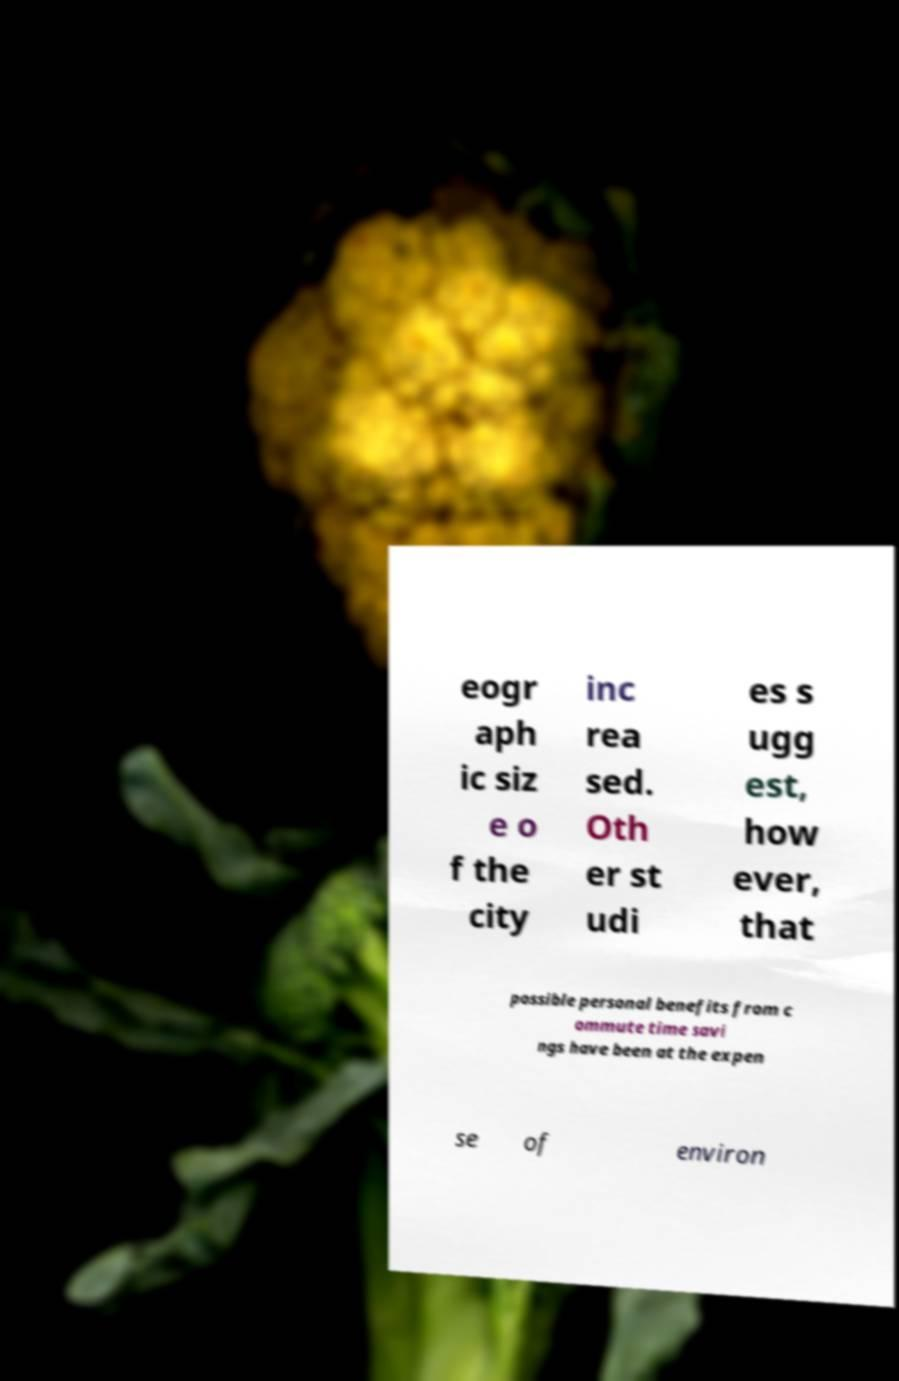Please identify and transcribe the text found in this image. eogr aph ic siz e o f the city inc rea sed. Oth er st udi es s ugg est, how ever, that possible personal benefits from c ommute time savi ngs have been at the expen se of environ 